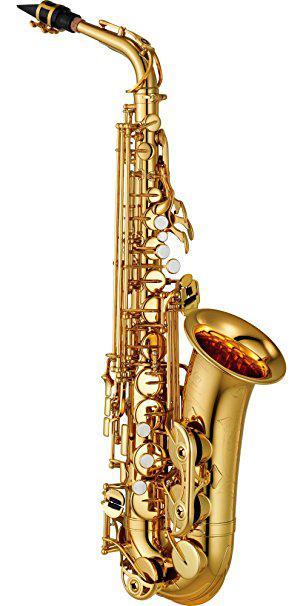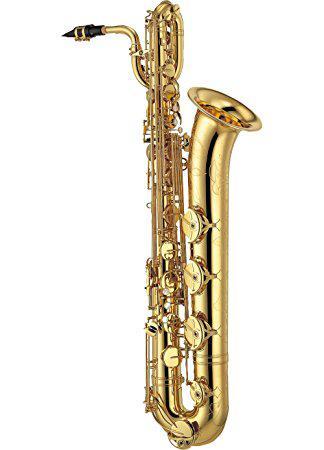The first image is the image on the left, the second image is the image on the right. Examine the images to the left and right. Is the description "Each image shows one upright gold colored saxophone with its bell facing rightward and its black-tipped mouthpiece facing leftward." accurate? Answer yes or no. Yes. The first image is the image on the left, the second image is the image on the right. For the images displayed, is the sentence "In at least one image that is a golden brass saxophone  with a black and gold mouth pieces." factually correct? Answer yes or no. Yes. 